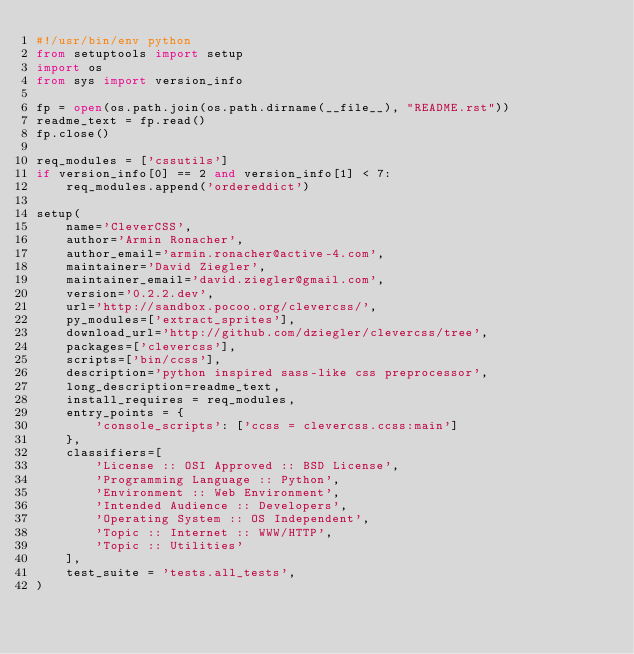<code> <loc_0><loc_0><loc_500><loc_500><_Python_>#!/usr/bin/env python
from setuptools import setup
import os
from sys import version_info

fp = open(os.path.join(os.path.dirname(__file__), "README.rst"))
readme_text = fp.read()
fp.close()

req_modules = ['cssutils']
if version_info[0] == 2 and version_info[1] < 7:
    req_modules.append('ordereddict')

setup(
    name='CleverCSS',
    author='Armin Ronacher',
    author_email='armin.ronacher@active-4.com',
    maintainer='David Ziegler',
    maintainer_email='david.ziegler@gmail.com',
    version='0.2.2.dev',
    url='http://sandbox.pocoo.org/clevercss/',
    py_modules=['extract_sprites'],
    download_url='http://github.com/dziegler/clevercss/tree',
    packages=['clevercss'],
    scripts=['bin/ccss'],
    description='python inspired sass-like css preprocessor',
    long_description=readme_text,
    install_requires = req_modules,
    entry_points = {
        'console_scripts': ['ccss = clevercss.ccss:main']
    },
    classifiers=[
        'License :: OSI Approved :: BSD License',
        'Programming Language :: Python',
        'Environment :: Web Environment',
        'Intended Audience :: Developers',
        'Operating System :: OS Independent',
        'Topic :: Internet :: WWW/HTTP',
        'Topic :: Utilities'
    ],
    test_suite = 'tests.all_tests',
)
</code> 